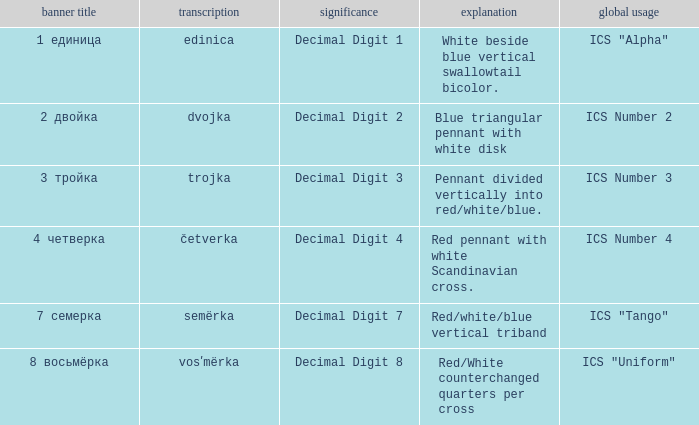How many different descriptions are there for the flag that means decimal digit 2? 1.0. 